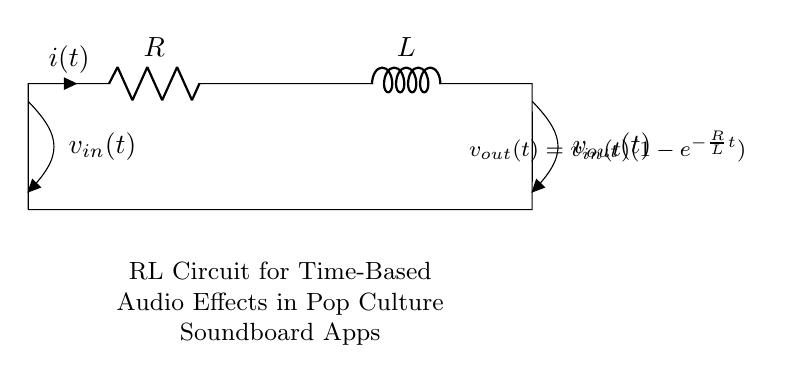What are the components present in this circuit? The circuit consists of a resistor (R) and an inductor (L), which are clearly labeled.
Answer: Resistor and Inductor What is the output voltage equation represented in the circuit? The equation for output voltage is given as v_out(t) = v_in(t)(1-e^(-R/L t)), which is shown in the diagram.
Answer: v_out(t) = v_in(t)(1-e^(-R/L t)) What does the current through the resistor and inductor represent? The current i(t) arrow denotes the flow of current through the circuit, specifically through the resistor.
Answer: i(t) What happens to the output voltage as time approaches infinity? As time approaches infinity, the term e^(-R/L t) approaches zero, leading v_out(t) to equal v_in(t).
Answer: v_in(t) What is the significance of the inductor in this RL circuit? The inductor stores energy in a magnetic field when current flows through it, affecting the time constant and response of the circuit.
Answer: Energy storage 